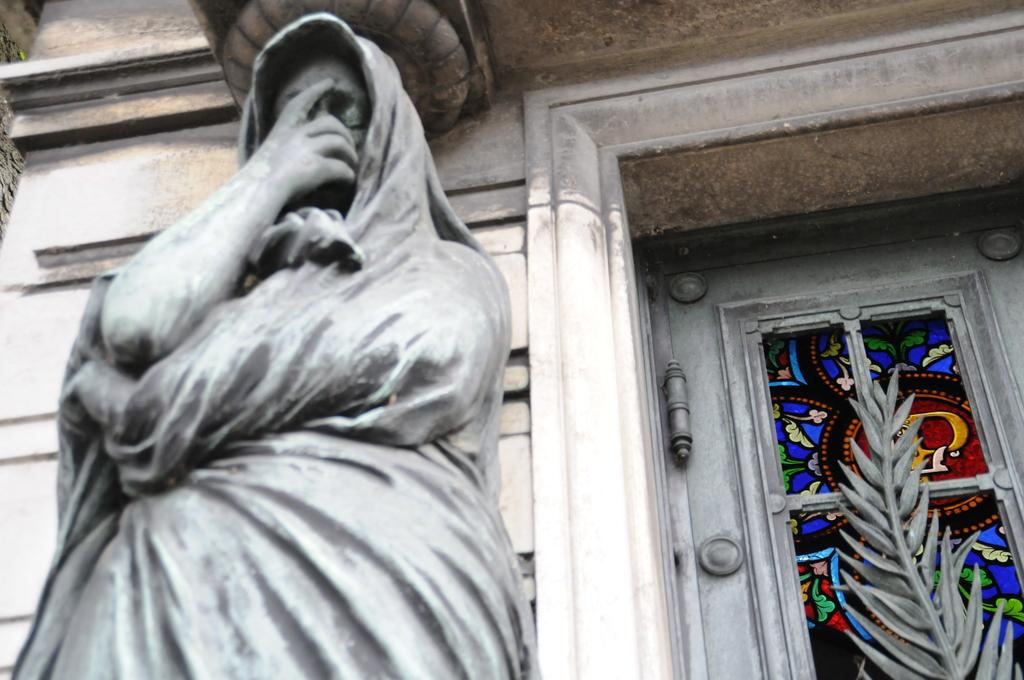What type of objects are in the front of the image? There are sculptures in the front of the image. Can you describe the sculptures in more detail? Unfortunately, the provided facts do not offer more details about the sculptures. What is the primary focus of the image? The primary focus of the image is the sculptures in the front. What type of advertisement can be seen in the frame of the image? There is no advertisement or frame present in the image; it only features sculptures in the front. 